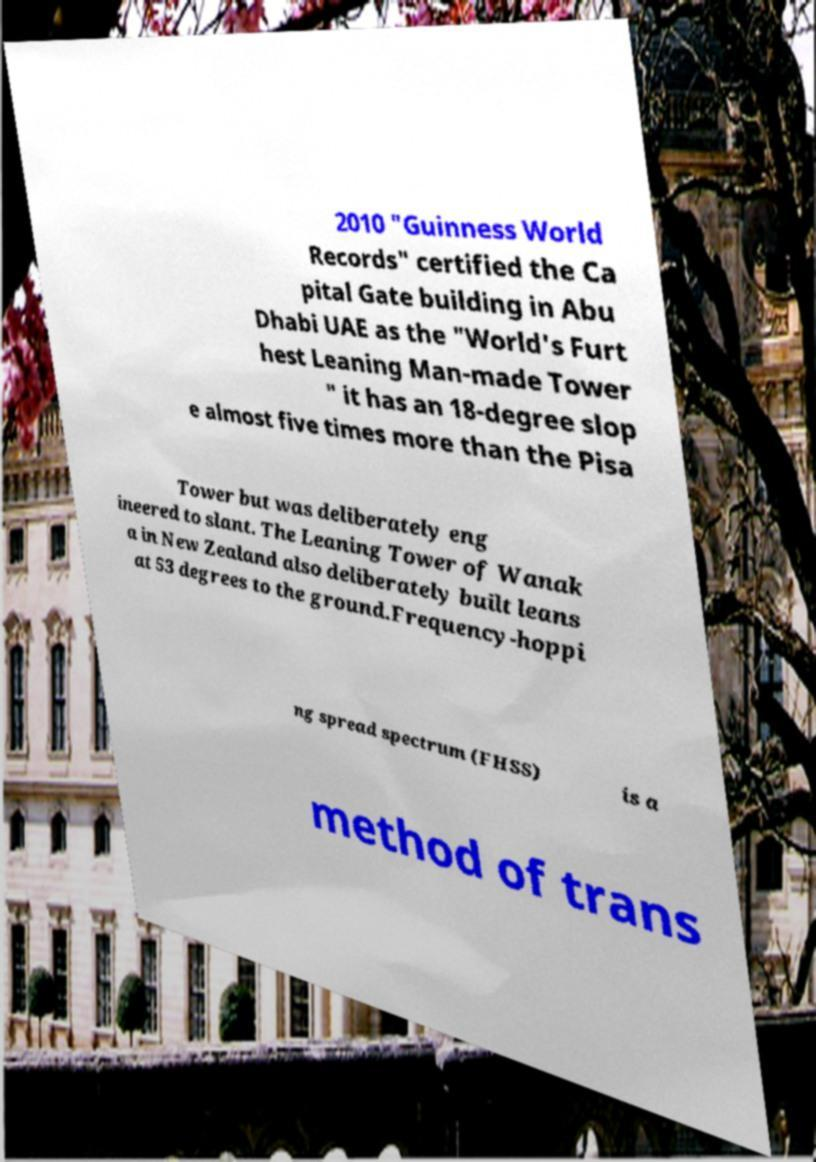Can you read and provide the text displayed in the image?This photo seems to have some interesting text. Can you extract and type it out for me? 2010 "Guinness World Records" certified the Ca pital Gate building in Abu Dhabi UAE as the "World's Furt hest Leaning Man-made Tower " it has an 18-degree slop e almost five times more than the Pisa Tower but was deliberately eng ineered to slant. The Leaning Tower of Wanak a in New Zealand also deliberately built leans at 53 degrees to the ground.Frequency-hoppi ng spread spectrum (FHSS) is a method of trans 